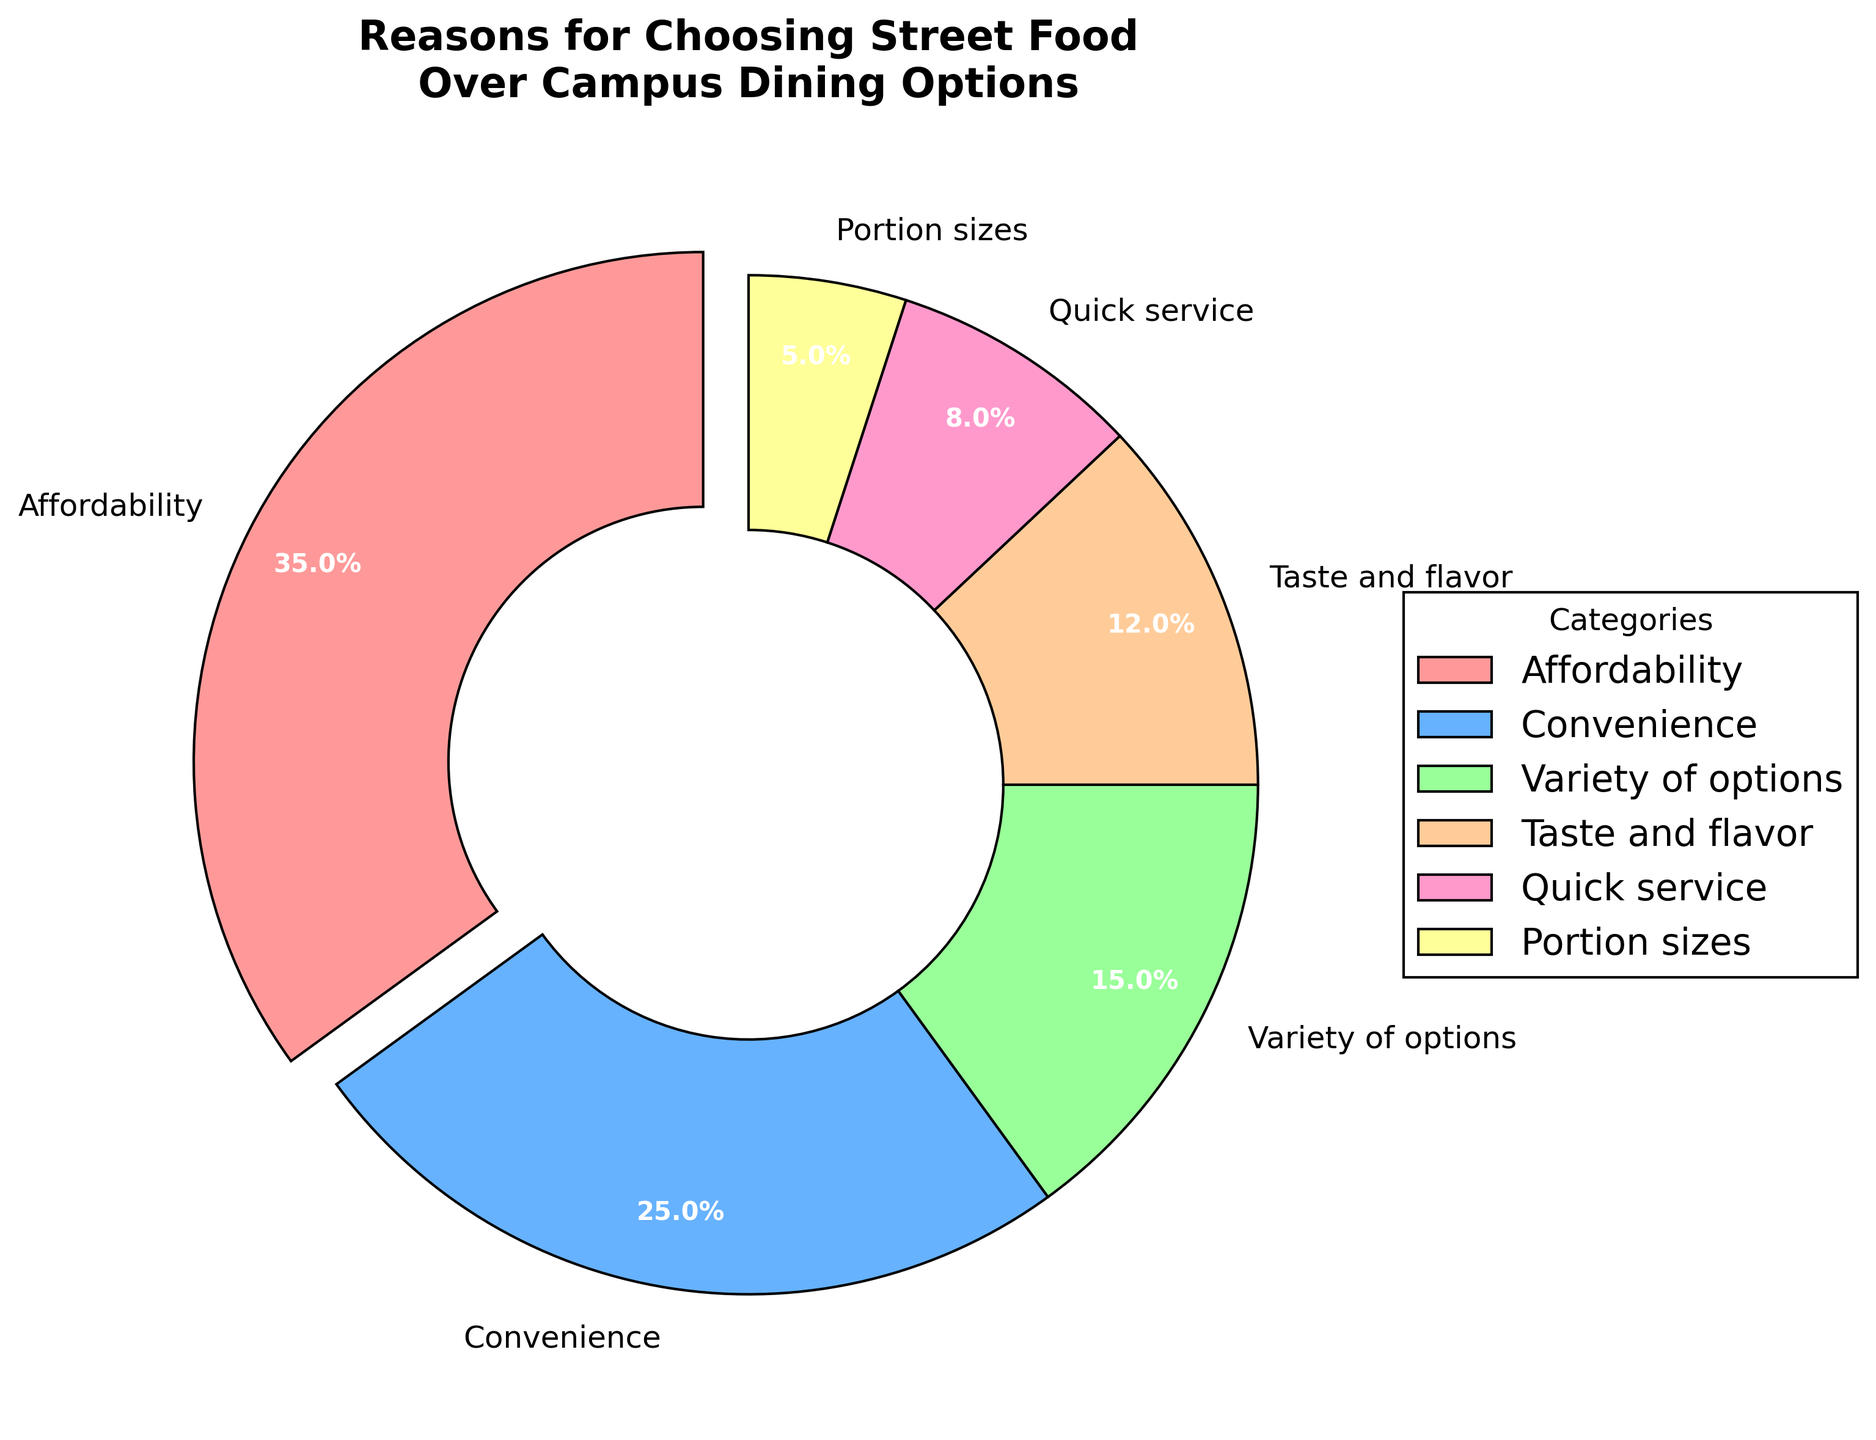What's the largest reason for choosing street food over campus dining options? The largest category can be identified by the largest slice in the pie chart. The "Affordability" slice is the largest, comprising 35%.
Answer: Affordability Which reason is the smallest for choosing street food? The smallest portion in the pie chart represents "Portion sizes", constituting only 5% of the total reasons.
Answer: Portion sizes What is the total percentage for reasons related to food preference (Taste and flavor + Variety of options)? Add the percentages for "Taste and flavor" (12%) and "Variety of options" (15%). The total is 12% + 15% = 27%.
Answer: 27% How much larger is the convenience percentage compared to quick service? Subtract the percentage of "Quick service" from "Convenience". Convenience is 25% and Quick service is 8%, so 25% - 8% = 17%.
Answer: 17% What fraction of the pie is dedicated to "Taste and flavor" and "Portion sizes" combined? Adding the percentages of "Taste and flavor" (12%) and "Portion sizes" (5%) gives 12% + 5% = 17%.
Answer: 17% Which categories have slices in the pie chart that are greater than 10%? The slices that exceed 10% are "Affordability" (35%), "Convenience" (25%), and "Variety of options" (15%), and "Taste and flavor" (12%). Since all of these are greater than 10%.
Answer: Affordability, Convenience, Variety of options, Taste and flavor Explain why the pie chart uses different colors and what benefits it provides? The pie chart uses different colors for each category to visually differentiate them, making it easier to identify and compare the slices at a glance. This enhances readability and comprehension.
Answer: To differentiate categories and enhance readability 